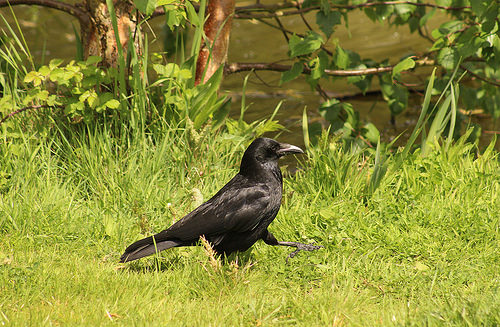<image>
Can you confirm if the grass is in front of the crow? No. The grass is not in front of the crow. The spatial positioning shows a different relationship between these objects. 